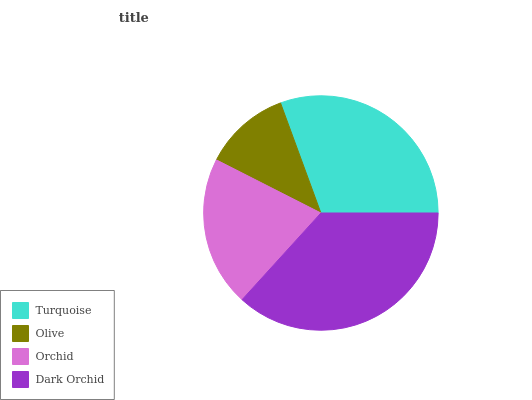Is Olive the minimum?
Answer yes or no. Yes. Is Dark Orchid the maximum?
Answer yes or no. Yes. Is Orchid the minimum?
Answer yes or no. No. Is Orchid the maximum?
Answer yes or no. No. Is Orchid greater than Olive?
Answer yes or no. Yes. Is Olive less than Orchid?
Answer yes or no. Yes. Is Olive greater than Orchid?
Answer yes or no. No. Is Orchid less than Olive?
Answer yes or no. No. Is Turquoise the high median?
Answer yes or no. Yes. Is Orchid the low median?
Answer yes or no. Yes. Is Dark Orchid the high median?
Answer yes or no. No. Is Turquoise the low median?
Answer yes or no. No. 